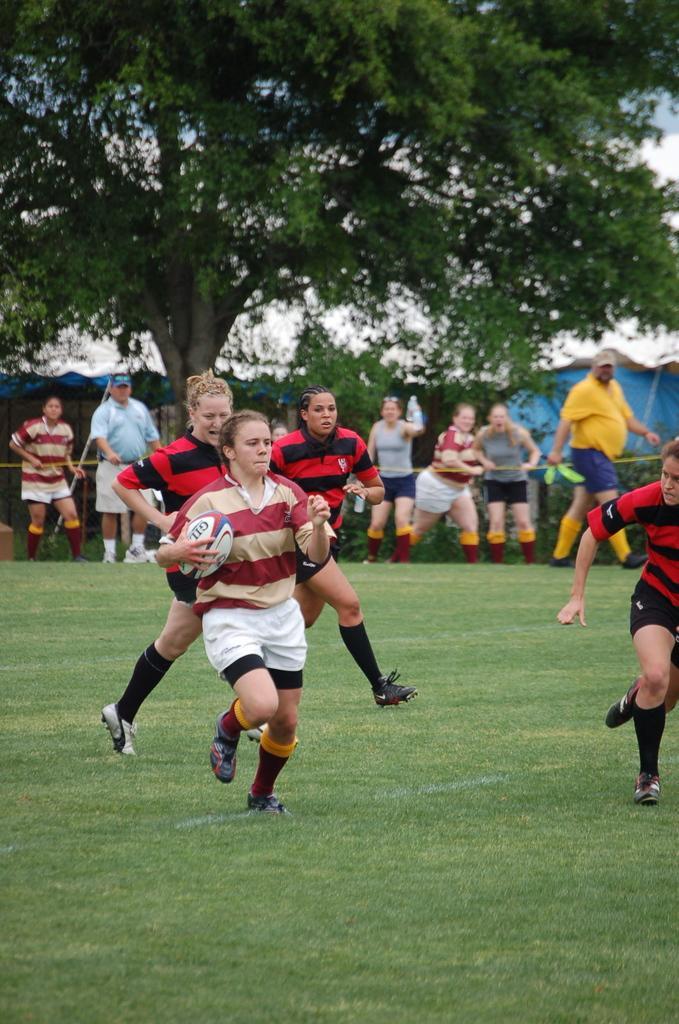How would you summarize this image in a sentence or two? This is the picture of place where we have some people, among them a person is holding the ball and behind there are some other people and some trees, plants. 